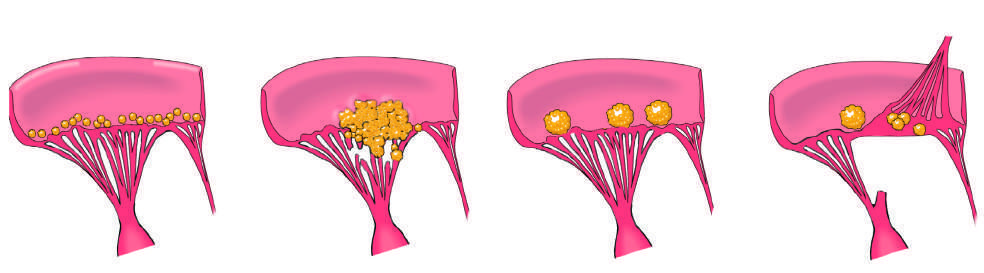s libman-sacks endocarditis characterized by small - to medium-sized inflammatory vegetations that can be attached on either side of the valve leaflets?
Answer the question using a single word or phrase. Yes 